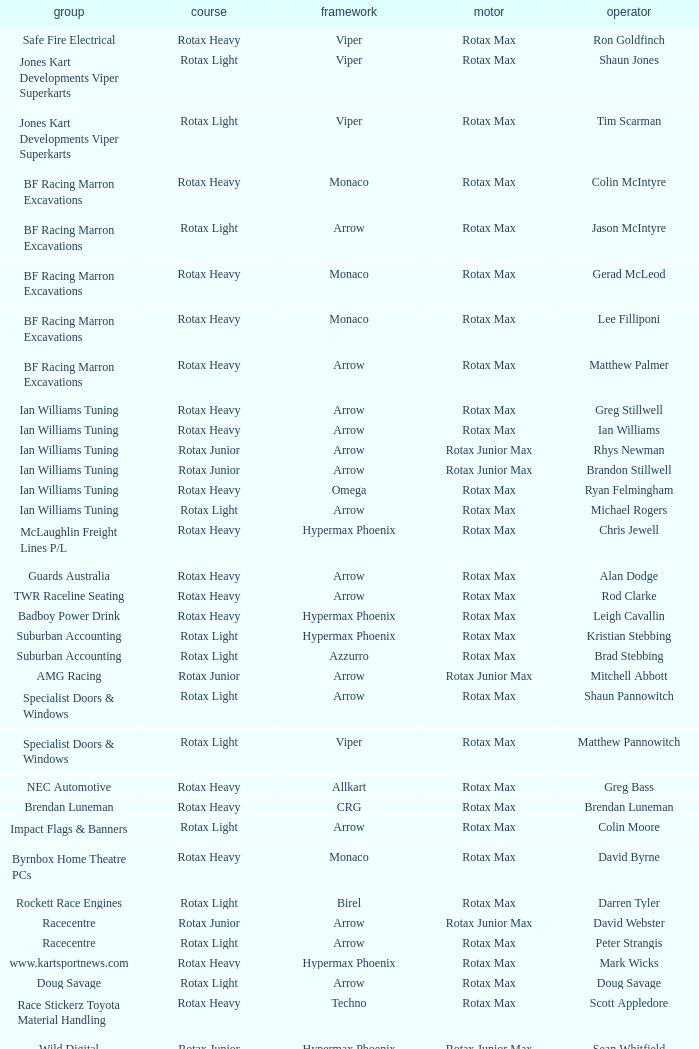What is the name of the driver with a rotax max engine, in the rotax heavy class, with arrow as chassis and on the TWR Raceline Seating team? Rod Clarke. 